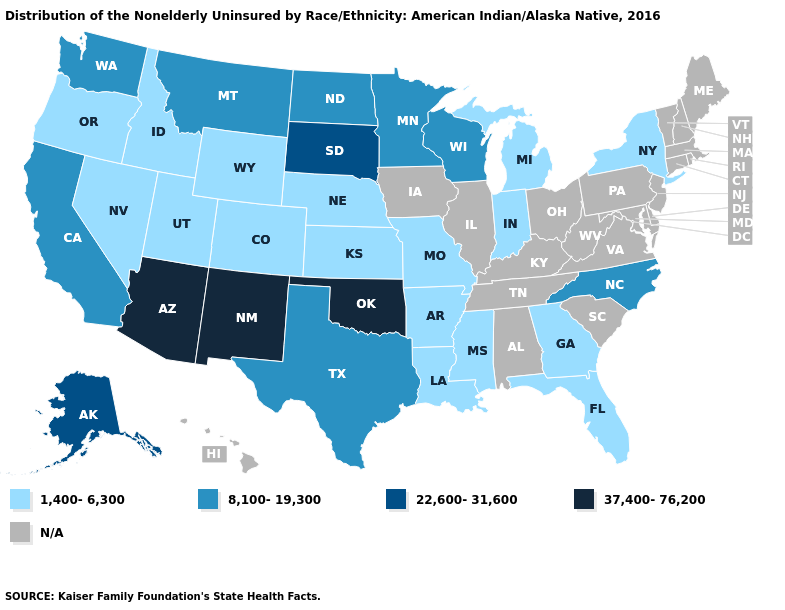What is the value of Alaska?
Concise answer only. 22,600-31,600. What is the highest value in the USA?
Concise answer only. 37,400-76,200. How many symbols are there in the legend?
Give a very brief answer. 5. Name the states that have a value in the range 22,600-31,600?
Write a very short answer. Alaska, South Dakota. What is the highest value in the USA?
Short answer required. 37,400-76,200. What is the value of North Carolina?
Quick response, please. 8,100-19,300. Name the states that have a value in the range 1,400-6,300?
Keep it brief. Arkansas, Colorado, Florida, Georgia, Idaho, Indiana, Kansas, Louisiana, Michigan, Mississippi, Missouri, Nebraska, Nevada, New York, Oregon, Utah, Wyoming. Name the states that have a value in the range 1,400-6,300?
Short answer required. Arkansas, Colorado, Florida, Georgia, Idaho, Indiana, Kansas, Louisiana, Michigan, Mississippi, Missouri, Nebraska, Nevada, New York, Oregon, Utah, Wyoming. Among the states that border Tennessee , which have the highest value?
Keep it brief. North Carolina. Among the states that border Colorado , which have the lowest value?
Quick response, please. Kansas, Nebraska, Utah, Wyoming. Which states have the highest value in the USA?
Keep it brief. Arizona, New Mexico, Oklahoma. Name the states that have a value in the range 22,600-31,600?
Be succinct. Alaska, South Dakota. What is the lowest value in the MidWest?
Give a very brief answer. 1,400-6,300. Does South Dakota have the highest value in the USA?
Answer briefly. No. 